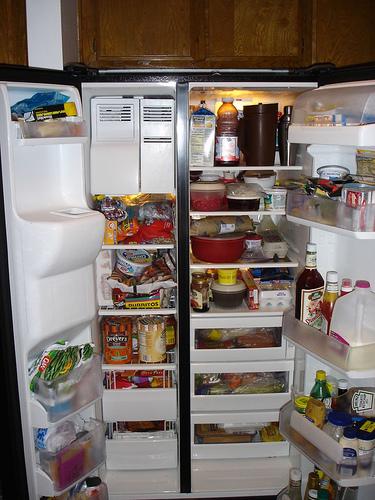Is the fridge empty?
Concise answer only. No. How many shelves does the refrigerator have?
Concise answer only. 7. How much milk is left in the jug?
Answer briefly. Half. Are the owners of this fridge poor?
Write a very short answer. No. How many containers of ice cream?
Concise answer only. 2. 